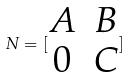<formula> <loc_0><loc_0><loc_500><loc_500>N = [ \begin{matrix} A & B \\ 0 & C \end{matrix} ]</formula> 